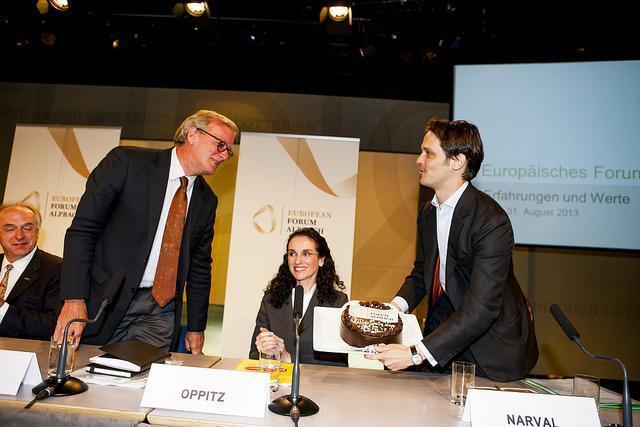How many men in suits are there?
Give a very brief answer. 3. How many people can you see?
Give a very brief answer. 4. How many red umbrellas are there?
Give a very brief answer. 0. 